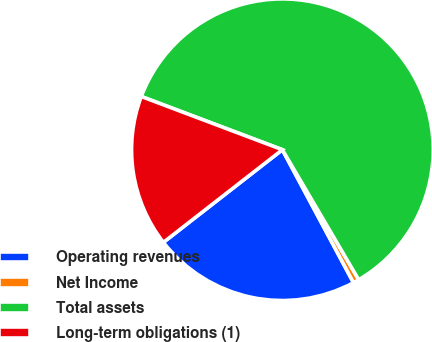Convert chart. <chart><loc_0><loc_0><loc_500><loc_500><pie_chart><fcel>Operating revenues<fcel>Net Income<fcel>Total assets<fcel>Long-term obligations (1)<nl><fcel>22.29%<fcel>0.63%<fcel>60.82%<fcel>16.27%<nl></chart> 